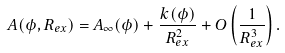Convert formula to latex. <formula><loc_0><loc_0><loc_500><loc_500>A ( \phi , R _ { e x } ) = A _ { \infty } ( \phi ) + \frac { k ( \phi ) } { R _ { e x } ^ { 2 } } + O \left ( \frac { 1 } { R _ { e x } ^ { 3 } } \right ) .</formula> 